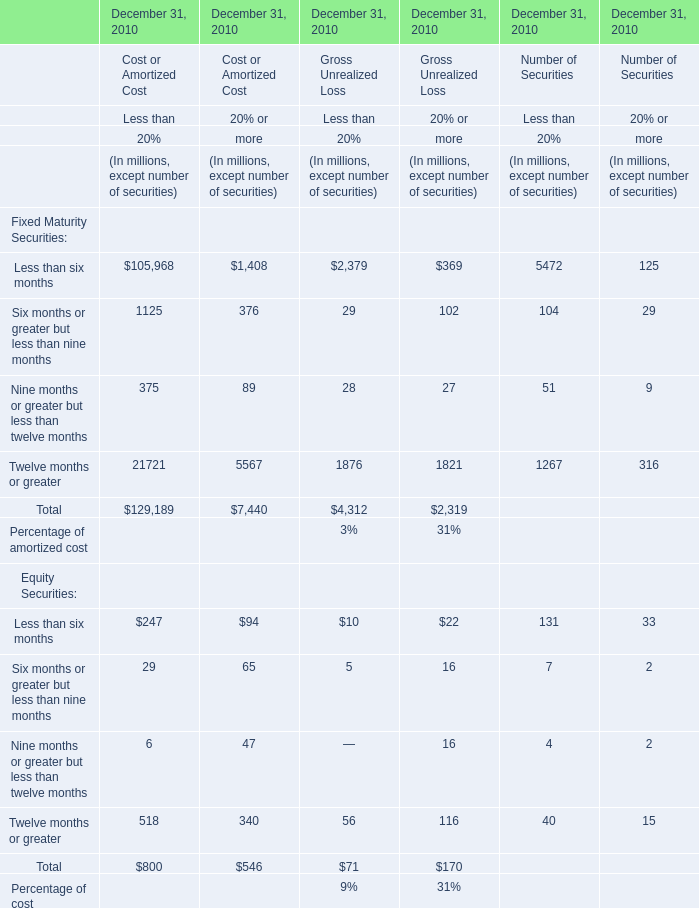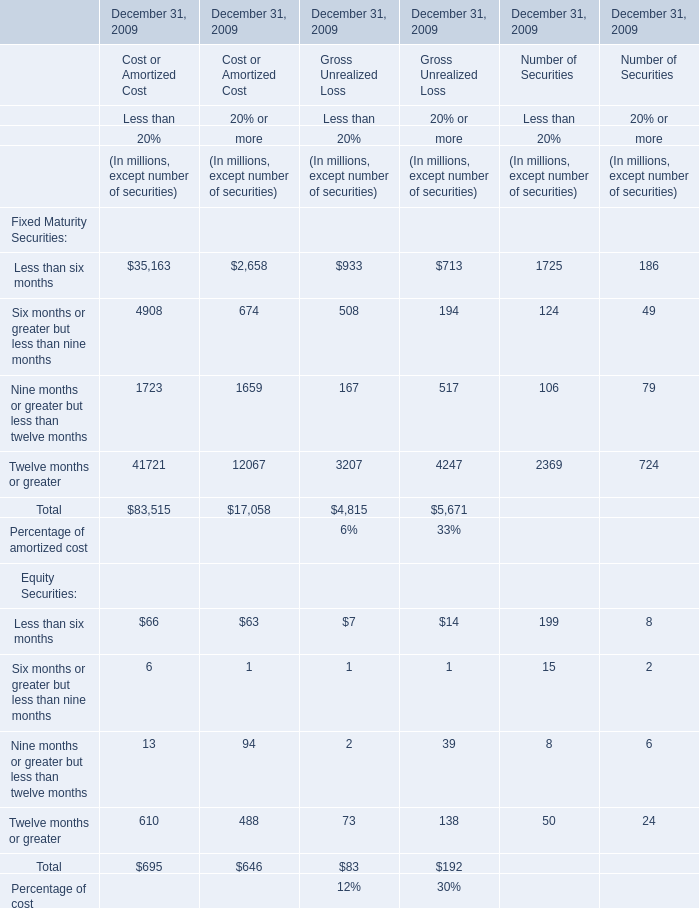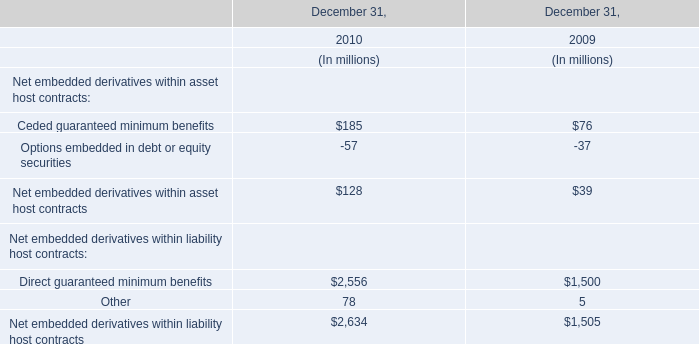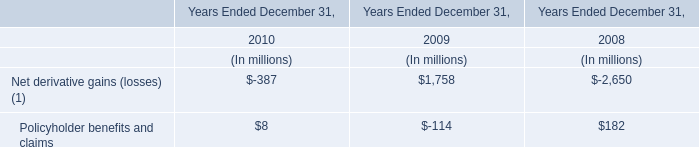What is the Gross Unrealized Loss in terms of Less than 20% for the Total Fixed Maturity Securities at December 31, 2010? (in million) 
Answer: 4312. 